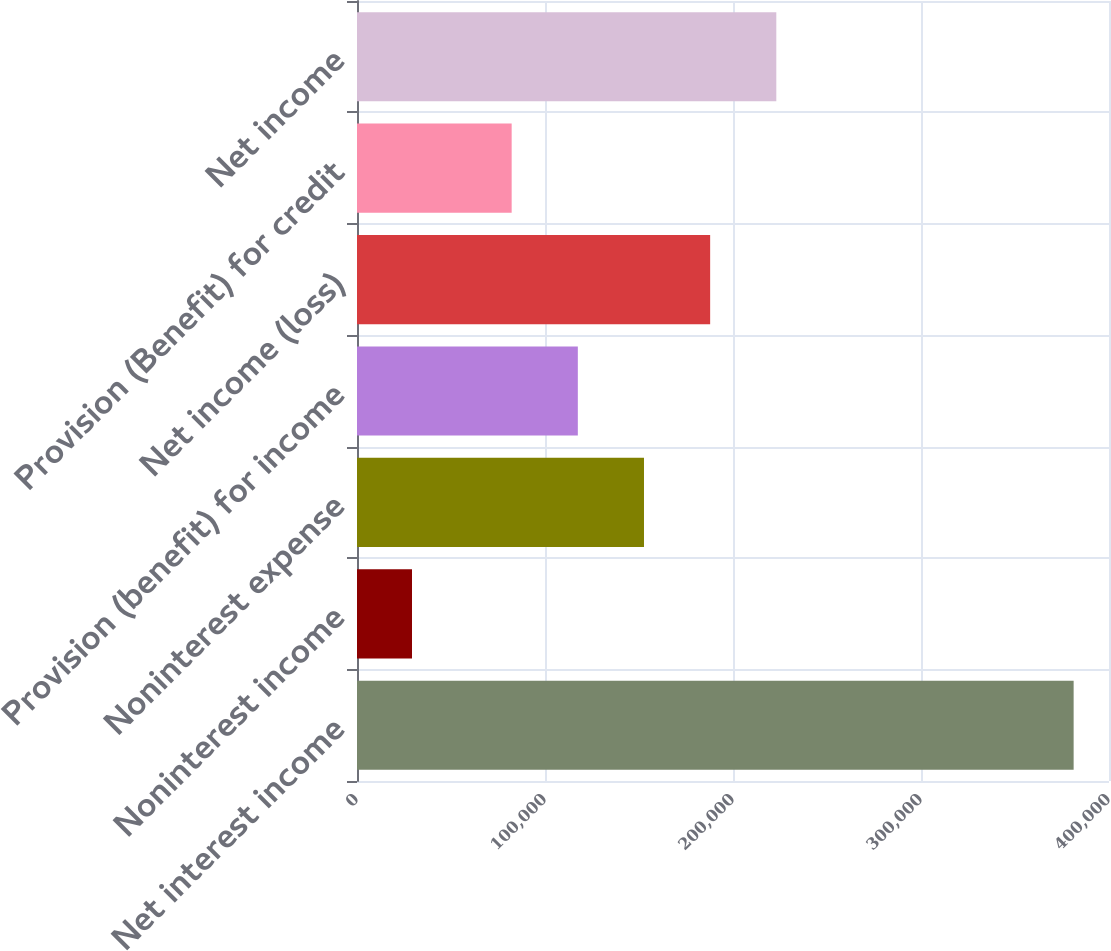Convert chart. <chart><loc_0><loc_0><loc_500><loc_500><bar_chart><fcel>Net interest income<fcel>Noninterest income<fcel>Noninterest expense<fcel>Provision (benefit) for income<fcel>Net income (loss)<fcel>Provision (Benefit) for credit<fcel>Net income<nl><fcel>381189<fcel>29257<fcel>152655<fcel>117462<fcel>187849<fcel>82269<fcel>223042<nl></chart> 